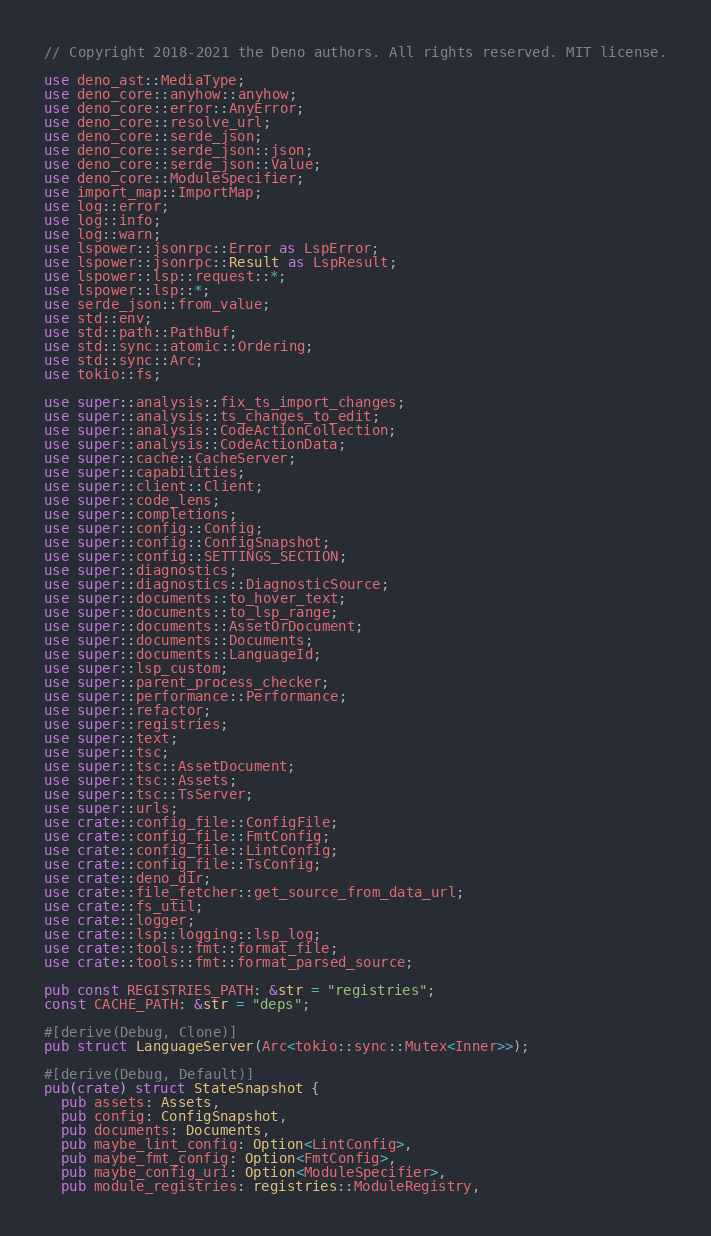<code> <loc_0><loc_0><loc_500><loc_500><_Rust_>// Copyright 2018-2021 the Deno authors. All rights reserved. MIT license.

use deno_ast::MediaType;
use deno_core::anyhow::anyhow;
use deno_core::error::AnyError;
use deno_core::resolve_url;
use deno_core::serde_json;
use deno_core::serde_json::json;
use deno_core::serde_json::Value;
use deno_core::ModuleSpecifier;
use import_map::ImportMap;
use log::error;
use log::info;
use log::warn;
use lspower::jsonrpc::Error as LspError;
use lspower::jsonrpc::Result as LspResult;
use lspower::lsp::request::*;
use lspower::lsp::*;
use serde_json::from_value;
use std::env;
use std::path::PathBuf;
use std::sync::atomic::Ordering;
use std::sync::Arc;
use tokio::fs;

use super::analysis::fix_ts_import_changes;
use super::analysis::ts_changes_to_edit;
use super::analysis::CodeActionCollection;
use super::analysis::CodeActionData;
use super::cache::CacheServer;
use super::capabilities;
use super::client::Client;
use super::code_lens;
use super::completions;
use super::config::Config;
use super::config::ConfigSnapshot;
use super::config::SETTINGS_SECTION;
use super::diagnostics;
use super::diagnostics::DiagnosticSource;
use super::documents::to_hover_text;
use super::documents::to_lsp_range;
use super::documents::AssetOrDocument;
use super::documents::Documents;
use super::documents::LanguageId;
use super::lsp_custom;
use super::parent_process_checker;
use super::performance::Performance;
use super::refactor;
use super::registries;
use super::text;
use super::tsc;
use super::tsc::AssetDocument;
use super::tsc::Assets;
use super::tsc::TsServer;
use super::urls;
use crate::config_file::ConfigFile;
use crate::config_file::FmtConfig;
use crate::config_file::LintConfig;
use crate::config_file::TsConfig;
use crate::deno_dir;
use crate::file_fetcher::get_source_from_data_url;
use crate::fs_util;
use crate::logger;
use crate::lsp::logging::lsp_log;
use crate::tools::fmt::format_file;
use crate::tools::fmt::format_parsed_source;

pub const REGISTRIES_PATH: &str = "registries";
const CACHE_PATH: &str = "deps";

#[derive(Debug, Clone)]
pub struct LanguageServer(Arc<tokio::sync::Mutex<Inner>>);

#[derive(Debug, Default)]
pub(crate) struct StateSnapshot {
  pub assets: Assets,
  pub config: ConfigSnapshot,
  pub documents: Documents,
  pub maybe_lint_config: Option<LintConfig>,
  pub maybe_fmt_config: Option<FmtConfig>,
  pub maybe_config_uri: Option<ModuleSpecifier>,
  pub module_registries: registries::ModuleRegistry,</code> 